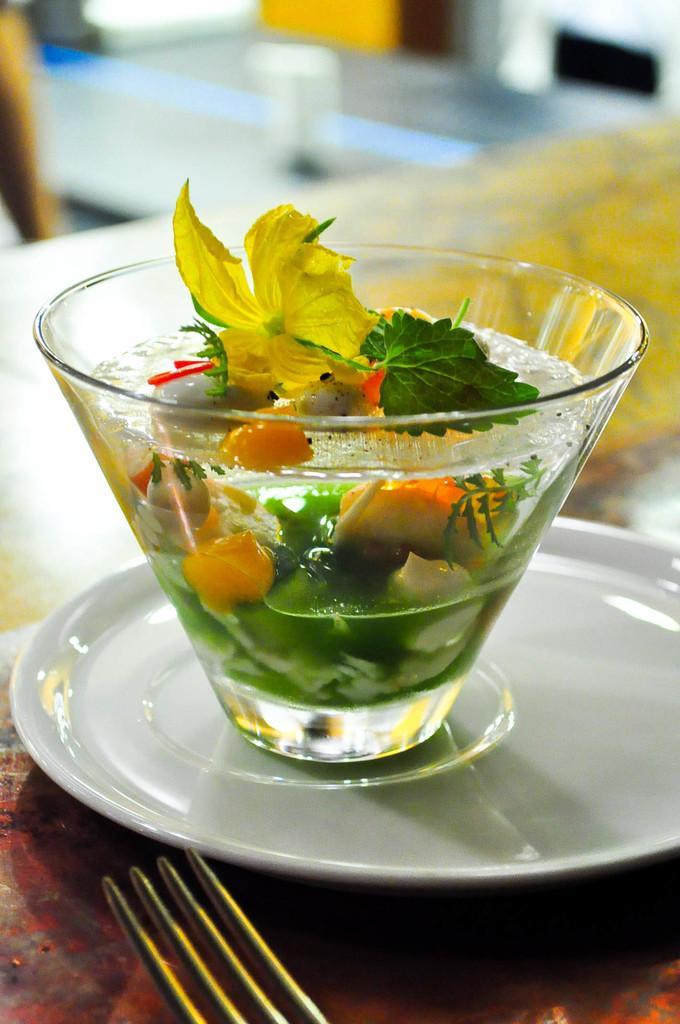Can you describe this image briefly? In this image I can see a white colour plate and on it I can see a glass. In the glass I can see few leaves, water and few other things. On the bottom left side of this image I can see a fork and I can also see this image is little bit blurry in the background. 